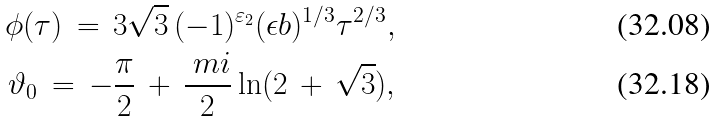<formula> <loc_0><loc_0><loc_500><loc_500>\phi ( \tau ) \, = \, 3 \sqrt { 3 } \, ( - 1 ) ^ { \varepsilon _ { 2 } } ( \epsilon b ) ^ { 1 / 3 } \tau ^ { 2 / 3 } , \\ \vartheta _ { 0 } \, = \, - \frac { \pi } { 2 } \, + \, \frac { \ m i } { 2 } \ln ( 2 \, + \, \sqrt { 3 } ) ,</formula> 